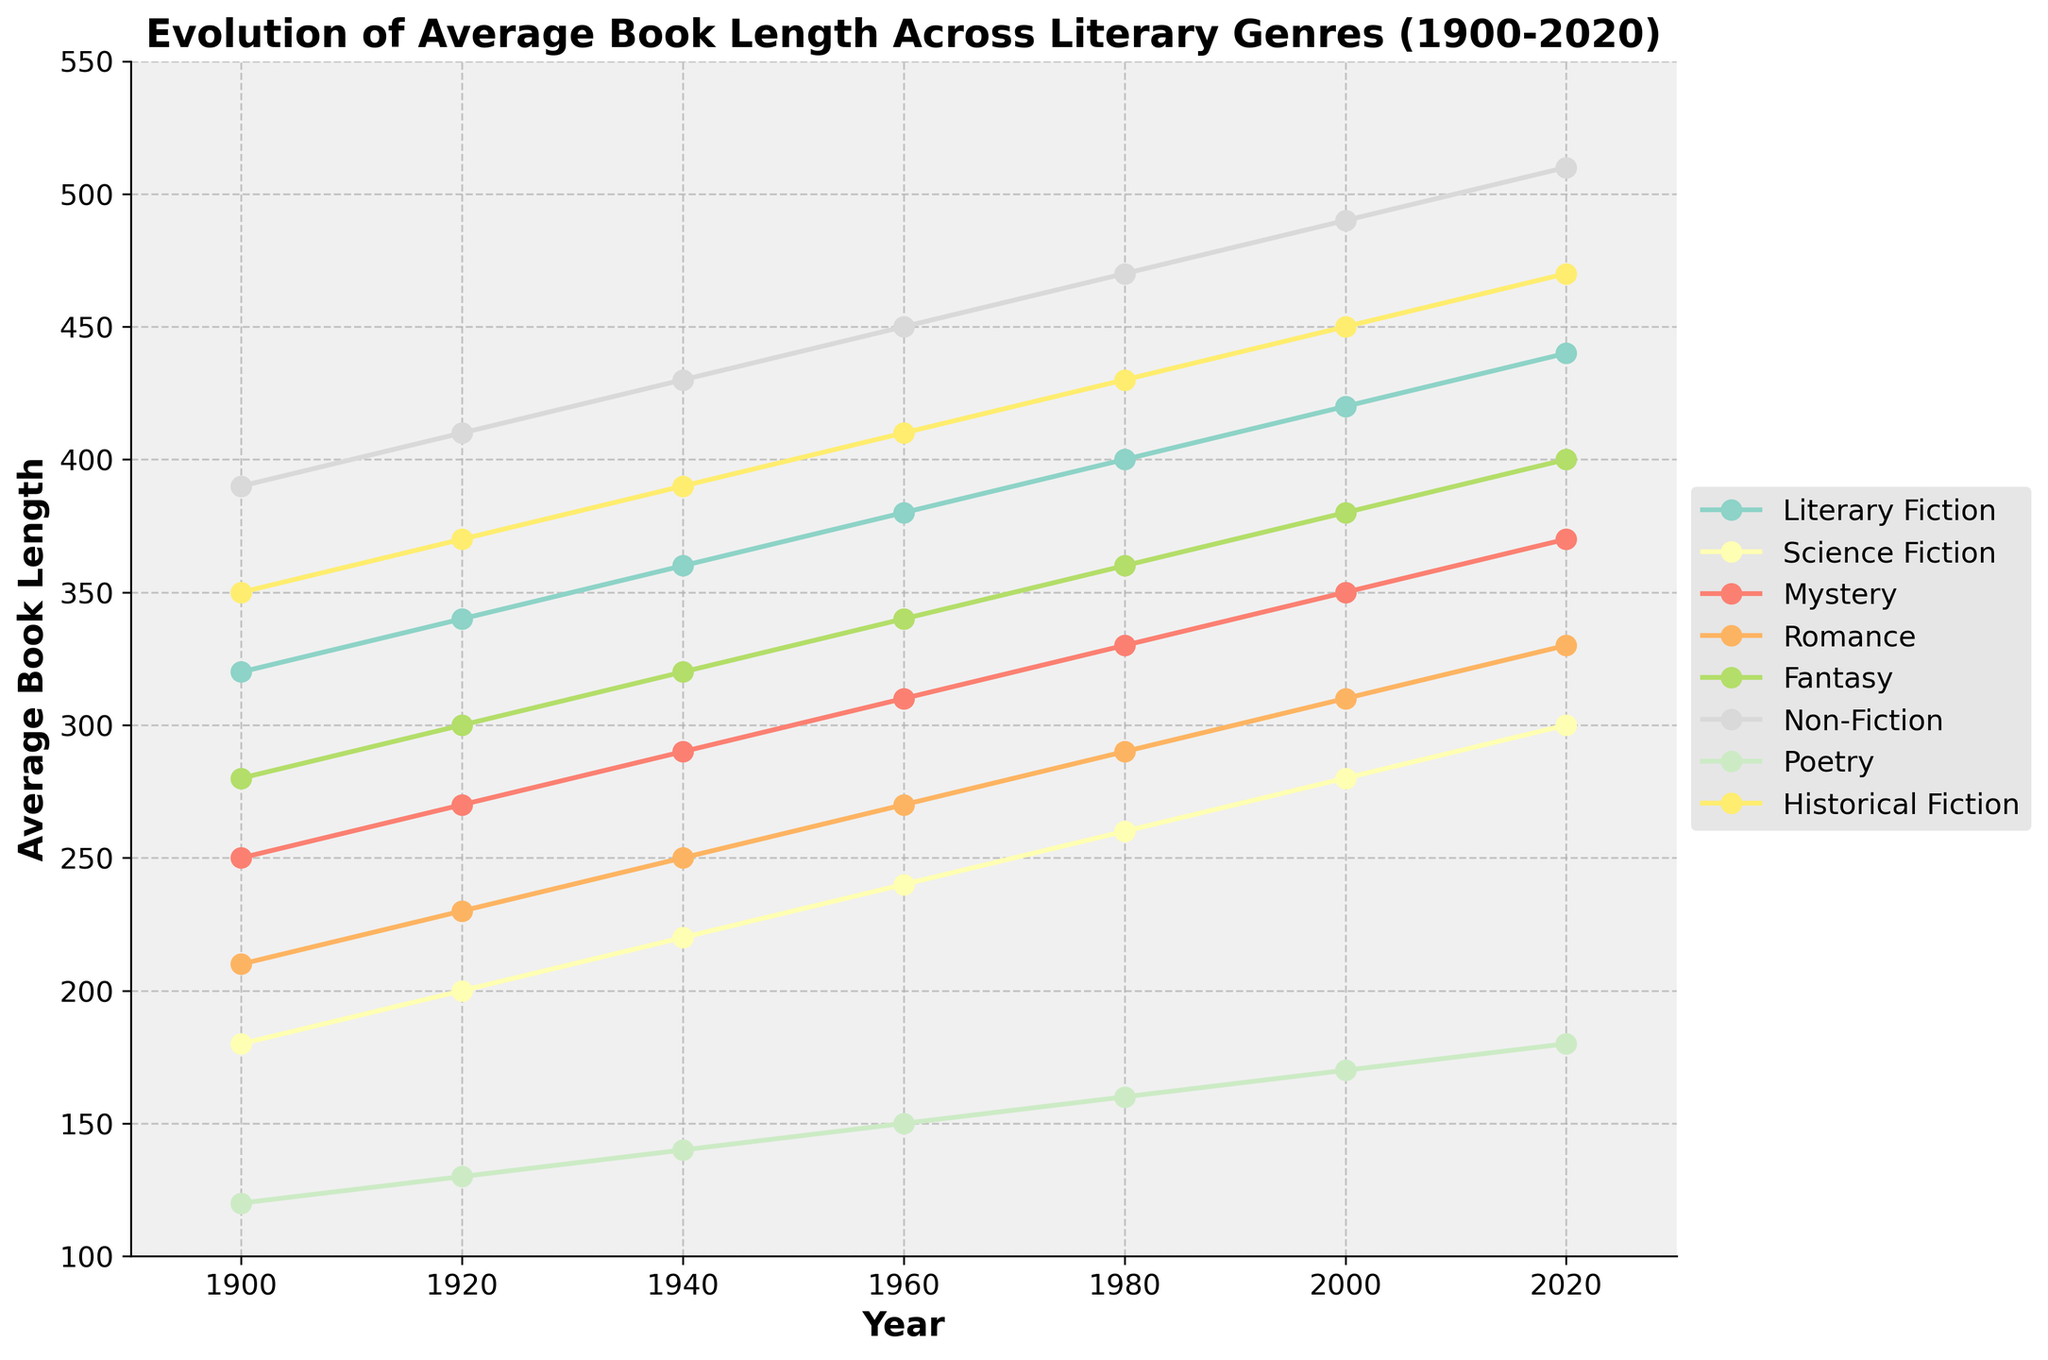What was the average length of Mystery and Romance books in 1960? To find the average, add the lengths of Mystery and Romance books in 1960, then divide by 2. The lengths are 310 (Mystery) and 270 (Romance). The average is (310 + 270) / 2 = 290.
Answer: 290 Which genre had the biggest increase in average book length from 1900 to 2020? Calculate the difference in average book length from 1900 to 2020 for each genre and compare them. The differences are: Literary Fiction: 440 - 320 = 120, Science Fiction: 300 - 180 = 120, Mystery: 370 - 250 = 120, Romance: 330 - 210 = 120, Fantasy: 400 - 280 = 120, Non-Fiction: 510 - 390 = 120, Poetry: 180 - 120 = 60, Historical Fiction: 470 - 350 = 120. Thus, the biggest increase is the same 120 for several genres: Literary Fiction, Science Fiction, Mystery, Romance, Fantasy, Non-Fiction, and Historical Fiction.
Answer: Literary Fiction, Science Fiction, Mystery, Romance, Fantasy, Non-Fiction, Historical Fiction Which genre had the smallest average book length in 2020? Look at the 2020 data points in the figure and identify the genre with the lowest value. Poetry's value is 180, which is the smallest among all genres.
Answer: Poetry What was the average length of books across all genres in 1940? Sum the average lengths of all genres in 1940 and divide by the number of genres (8). The lengths are 360, 220, 290, 250, 320, 430, 140, 390. The average is (360 + 220 + 290 + 250 + 320 + 430 + 140 + 390) / 8 = 300.
Answer: 300 Which genre has consistently had shorter average book lengths than Literary Fiction across all years shown? Compare the average book lengths across all years for each genre against Literary Fiction. All other genres (Science Fiction, Mystery, Romance, Fantasy, Non-Fiction, Poetry, Historical Fiction) have noticeably shorter lengths compared to Literary Fiction in each year.
Answer: Science Fiction, Mystery, Romance, Fantasy, Non-Fiction, Poetry, Historical Fiction What is the difference in average book length between Fantasy and Non-Fiction genres in 2000? To find the difference, subtract Fantasy's length from Non-Fiction's length in 2000. The values are 490 (Non-Fiction) and 380 (Fantasy). The difference is 490 - 380 = 110.
Answer: 110 In which decade did the average length of Romance books reach 300 pages or more for the first time? Look at the Romance trendline and identify when it first reaches or exceeds 300 pages. Romance books reached 310 pages in the year 2000.
Answer: 2000s 